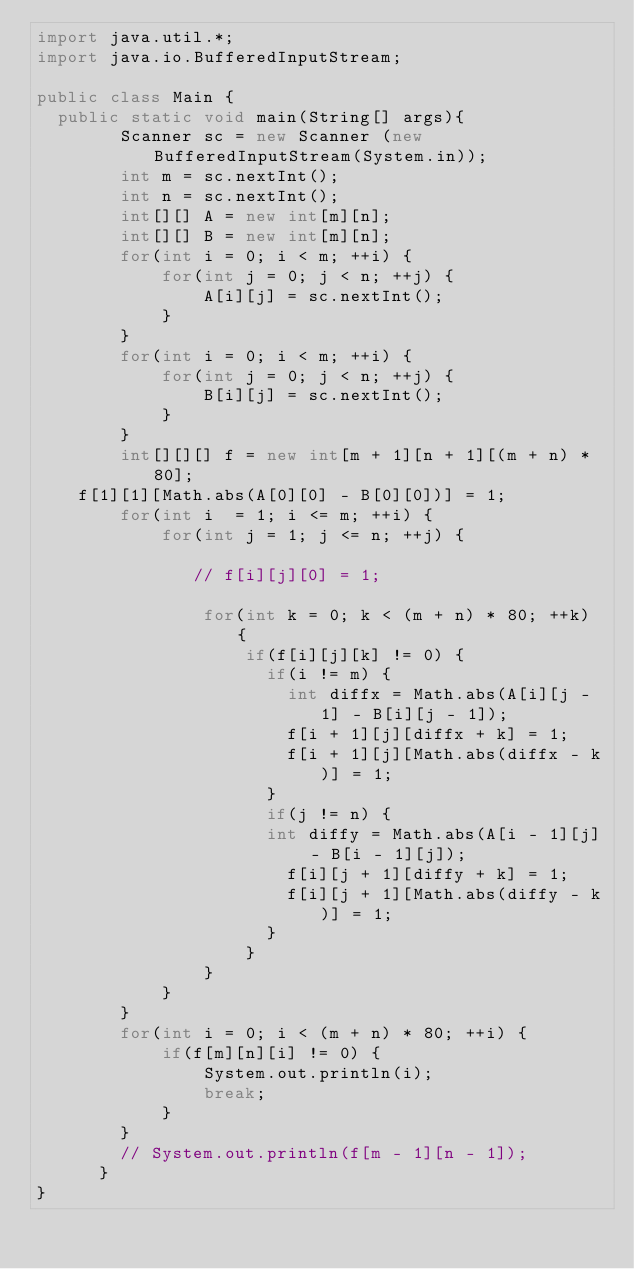<code> <loc_0><loc_0><loc_500><loc_500><_Java_>import java.util.*;
import java.io.BufferedInputStream;

public class Main {
  public static void main(String[] args){
        Scanner sc = new Scanner (new BufferedInputStream(System.in));
        int m = sc.nextInt();
        int n = sc.nextInt();
        int[][] A = new int[m][n];
        int[][] B = new int[m][n];
        for(int i = 0; i < m; ++i) {
            for(int j = 0; j < n; ++j) {
                A[i][j] = sc.nextInt();
            }
        }
        for(int i = 0; i < m; ++i) {
            for(int j = 0; j < n; ++j) {
                B[i][j] = sc.nextInt();
            }
        }
        int[][][] f = new int[m + 1][n + 1][(m + n) * 80];
    f[1][1][Math.abs(A[0][0] - B[0][0])] = 1;
        for(int i  = 1; i <= m; ++i) {
            for(int j = 1; j <= n; ++j) {

               // f[i][j][0] = 1;
                
                for(int k = 0; k < (m + n) * 80; ++k) {	
                    if(f[i][j][k] != 0) {
                      if(i != m) { 
                        int diffx = Math.abs(A[i][j - 1] - B[i][j - 1]);
                        f[i + 1][j][diffx + k] = 1;
                        f[i + 1][j][Math.abs(diffx - k)] = 1;
                      }
                      if(j != n) { 
                     	int diffy = Math.abs(A[i - 1][j] - B[i - 1][j]);
                        f[i][j + 1][diffy + k] = 1;
                        f[i][j + 1][Math.abs(diffy - k)] = 1;
                      }
                    }
                }
            }
        }
        for(int i = 0; i < (m + n) * 80; ++i) {
            if(f[m][n][i] != 0) {
                System.out.println(i);
                break;
            }
        }
        // System.out.println(f[m - 1][n - 1]);
      }
}
</code> 